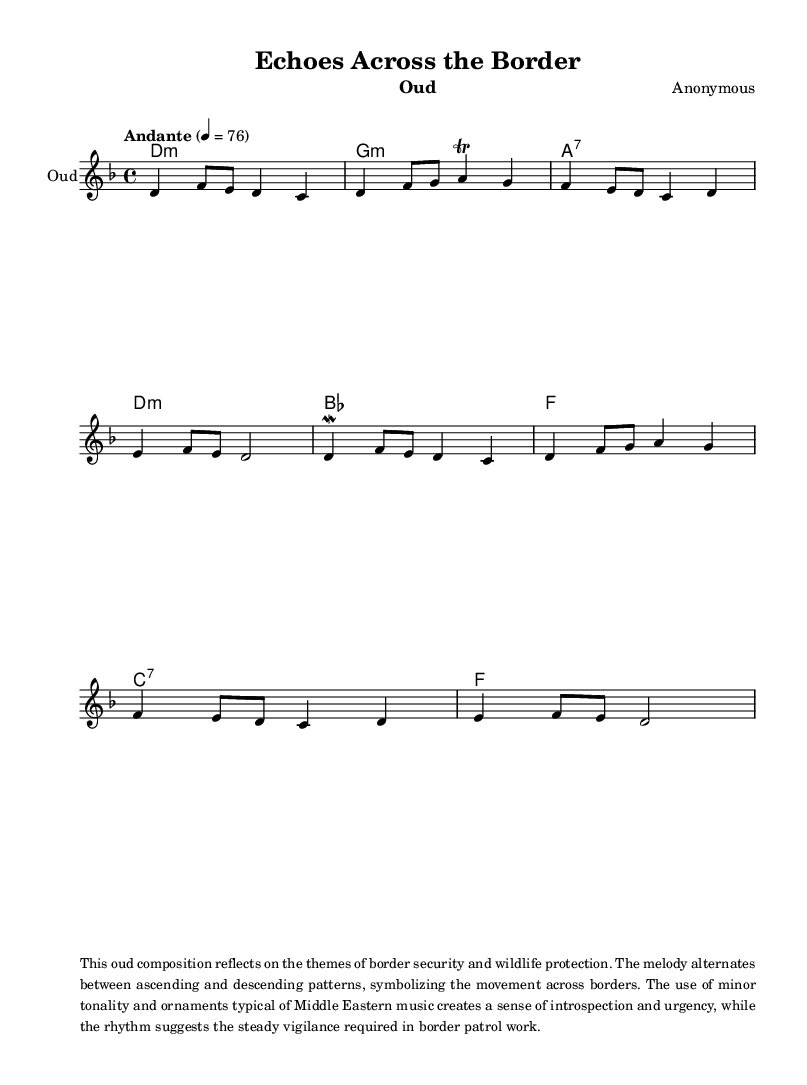What is the key signature of this music? The key signature is indicated by the 'key' command in the global section. It states 'd minor', which means the piece has one flat.
Answer: D minor What is the time signature of this music? The time signature is found in the global section as '4/4'. This denotes a common time signature used in many musical compositions.
Answer: 4/4 What is the tempo marking of this composition? The tempo is indicated as "Andante" with a metronome marking of 76. "Andante" describes a moderate speed, and the number gives a specific pacing.
Answer: Andante 76 How many measures are present in the melody? By counting the number of bar lines in the melody section, we can see there are 8 measures. Each bar line indicates the end of a measure.
Answer: 8 What musical ornament is used in the phrase on the second measure? The ornamentation in the second measure is indicated by a 'trill', which signifies rapid alternation between two adjacent notes.
Answer: Trill What is the primary theme reflected in this oud composition? The accompanying text markup describes that the themes of border security and wildlife protection are primary. It highlights the issues being addressed through the music.
Answer: Border security and wildlife protection What is the significance of the alternating patterns in the melody? The text also mentions that the melody alternates between ascending and descending patterns, symbolizing movement across borders which connects to the theme of traversing borders.
Answer: Movement across borders 